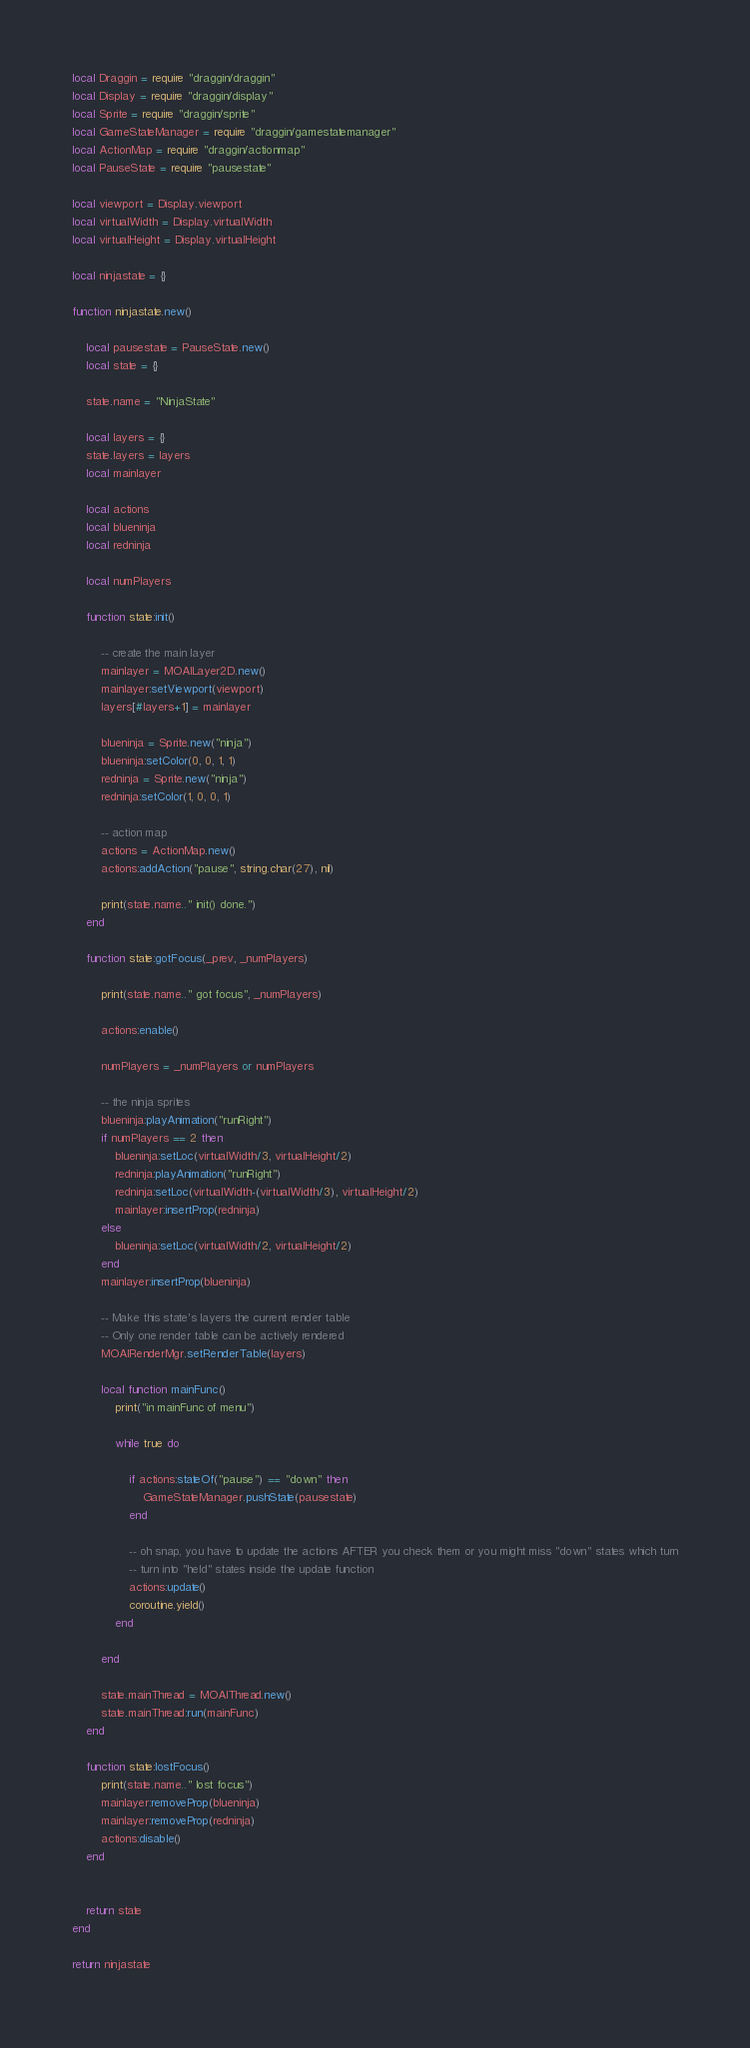Convert code to text. <code><loc_0><loc_0><loc_500><loc_500><_Lua_>local Draggin = require "draggin/draggin"
local Display = require "draggin/display"
local Sprite = require "draggin/sprite"
local GameStateManager = require "draggin/gamestatemanager"
local ActionMap = require "draggin/actionmap"
local PauseState = require "pausestate"

local viewport = Display.viewport
local virtualWidth = Display.virtualWidth
local virtualHeight = Display.virtualHeight

local ninjastate = {}

function ninjastate.new()

	local pausestate = PauseState.new()
	local state = {}

	state.name = "NinjaState"

	local layers = {}
	state.layers = layers
	local mainlayer

	local actions
	local blueninja
	local redninja

	local numPlayers

	function state:init()

		-- create the main layer
		mainlayer = MOAILayer2D.new()
		mainlayer:setViewport(viewport)
		layers[#layers+1] = mainlayer

		blueninja = Sprite.new("ninja")
		blueninja:setColor(0, 0, 1, 1)
		redninja = Sprite.new("ninja")
		redninja:setColor(1, 0, 0, 1)

		-- action map
		actions = ActionMap.new()
		actions:addAction("pause", string.char(27), nil)

		print(state.name.." init() done.")
	end

	function state:gotFocus(_prev, _numPlayers)

		print(state.name.." got focus", _numPlayers)

		actions:enable()

		numPlayers = _numPlayers or numPlayers

		-- the ninja sprites
		blueninja:playAnimation("runRight")
		if numPlayers == 2 then
			blueninja:setLoc(virtualWidth/3, virtualHeight/2)
			redninja:playAnimation("runRight")
			redninja:setLoc(virtualWidth-(virtualWidth/3), virtualHeight/2)
			mainlayer:insertProp(redninja)
		else
			blueninja:setLoc(virtualWidth/2, virtualHeight/2)
		end
		mainlayer:insertProp(blueninja)

		-- Make this state's layers the current render table
		-- Only one render table can be actively rendered
		MOAIRenderMgr.setRenderTable(layers)

		local function mainFunc()
			print("in mainFunc of menu")

			while true do

				if actions:stateOf("pause") == "down" then
					GameStateManager.pushState(pausestate)
				end

				-- oh snap, you have to update the actions AFTER you check them or you might miss "down" states which turn
				-- turn into "held" states inside the update function
				actions:update()
			 	coroutine.yield()
			end

		end

		state.mainThread = MOAIThread.new()
		state.mainThread:run(mainFunc)
	end

	function state:lostFocus()
		print(state.name.." lost focus")
		mainlayer:removeProp(blueninja)
		mainlayer:removeProp(redninja)
		actions:disable()
	end


	return state
end

return ninjastate
</code> 